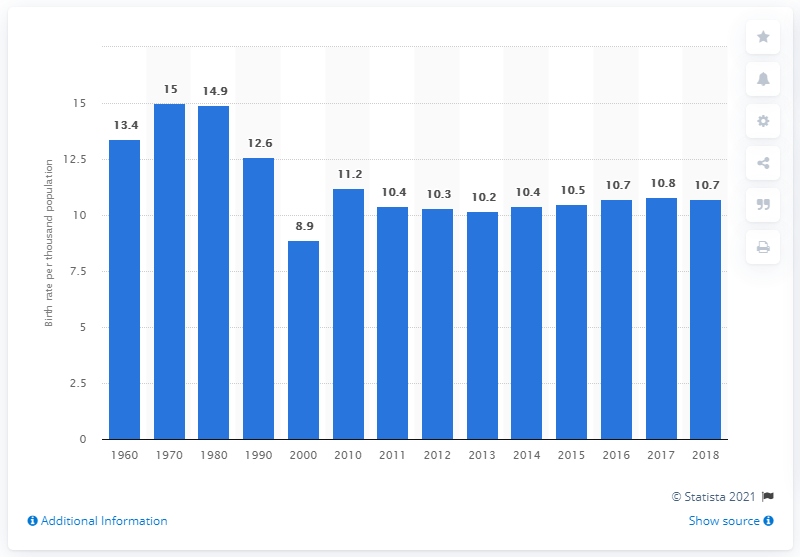Outline some significant characteristics in this image. In 2018, the crude birth rate in Czechia was 10.7 per 1,000 population. 